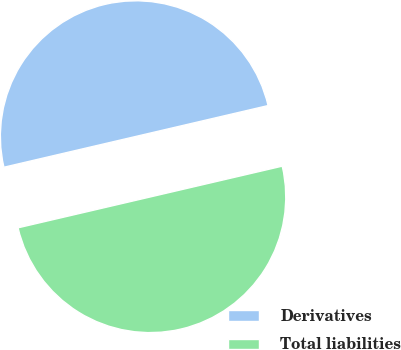Convert chart to OTSL. <chart><loc_0><loc_0><loc_500><loc_500><pie_chart><fcel>Derivatives<fcel>Total liabilities<nl><fcel>50.0%<fcel>50.0%<nl></chart> 